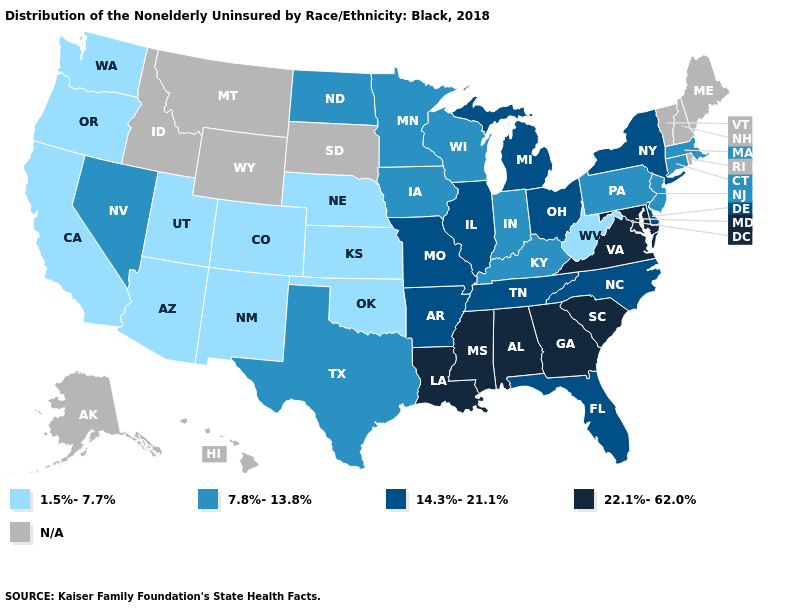Which states hav the highest value in the South?
Answer briefly. Alabama, Georgia, Louisiana, Maryland, Mississippi, South Carolina, Virginia. What is the value of Hawaii?
Concise answer only. N/A. What is the value of Oregon?
Quick response, please. 1.5%-7.7%. What is the value of North Dakota?
Keep it brief. 7.8%-13.8%. What is the lowest value in the USA?
Write a very short answer. 1.5%-7.7%. Does New Jersey have the lowest value in the Northeast?
Write a very short answer. Yes. Among the states that border South Carolina , does Georgia have the lowest value?
Give a very brief answer. No. What is the lowest value in the USA?
Keep it brief. 1.5%-7.7%. Among the states that border Massachusetts , which have the highest value?
Short answer required. New York. What is the value of Georgia?
Short answer required. 22.1%-62.0%. Does New Jersey have the lowest value in the USA?
Be succinct. No. Among the states that border North Dakota , which have the highest value?
Keep it brief. Minnesota. What is the value of Louisiana?
Short answer required. 22.1%-62.0%. Which states have the highest value in the USA?
Short answer required. Alabama, Georgia, Louisiana, Maryland, Mississippi, South Carolina, Virginia. 